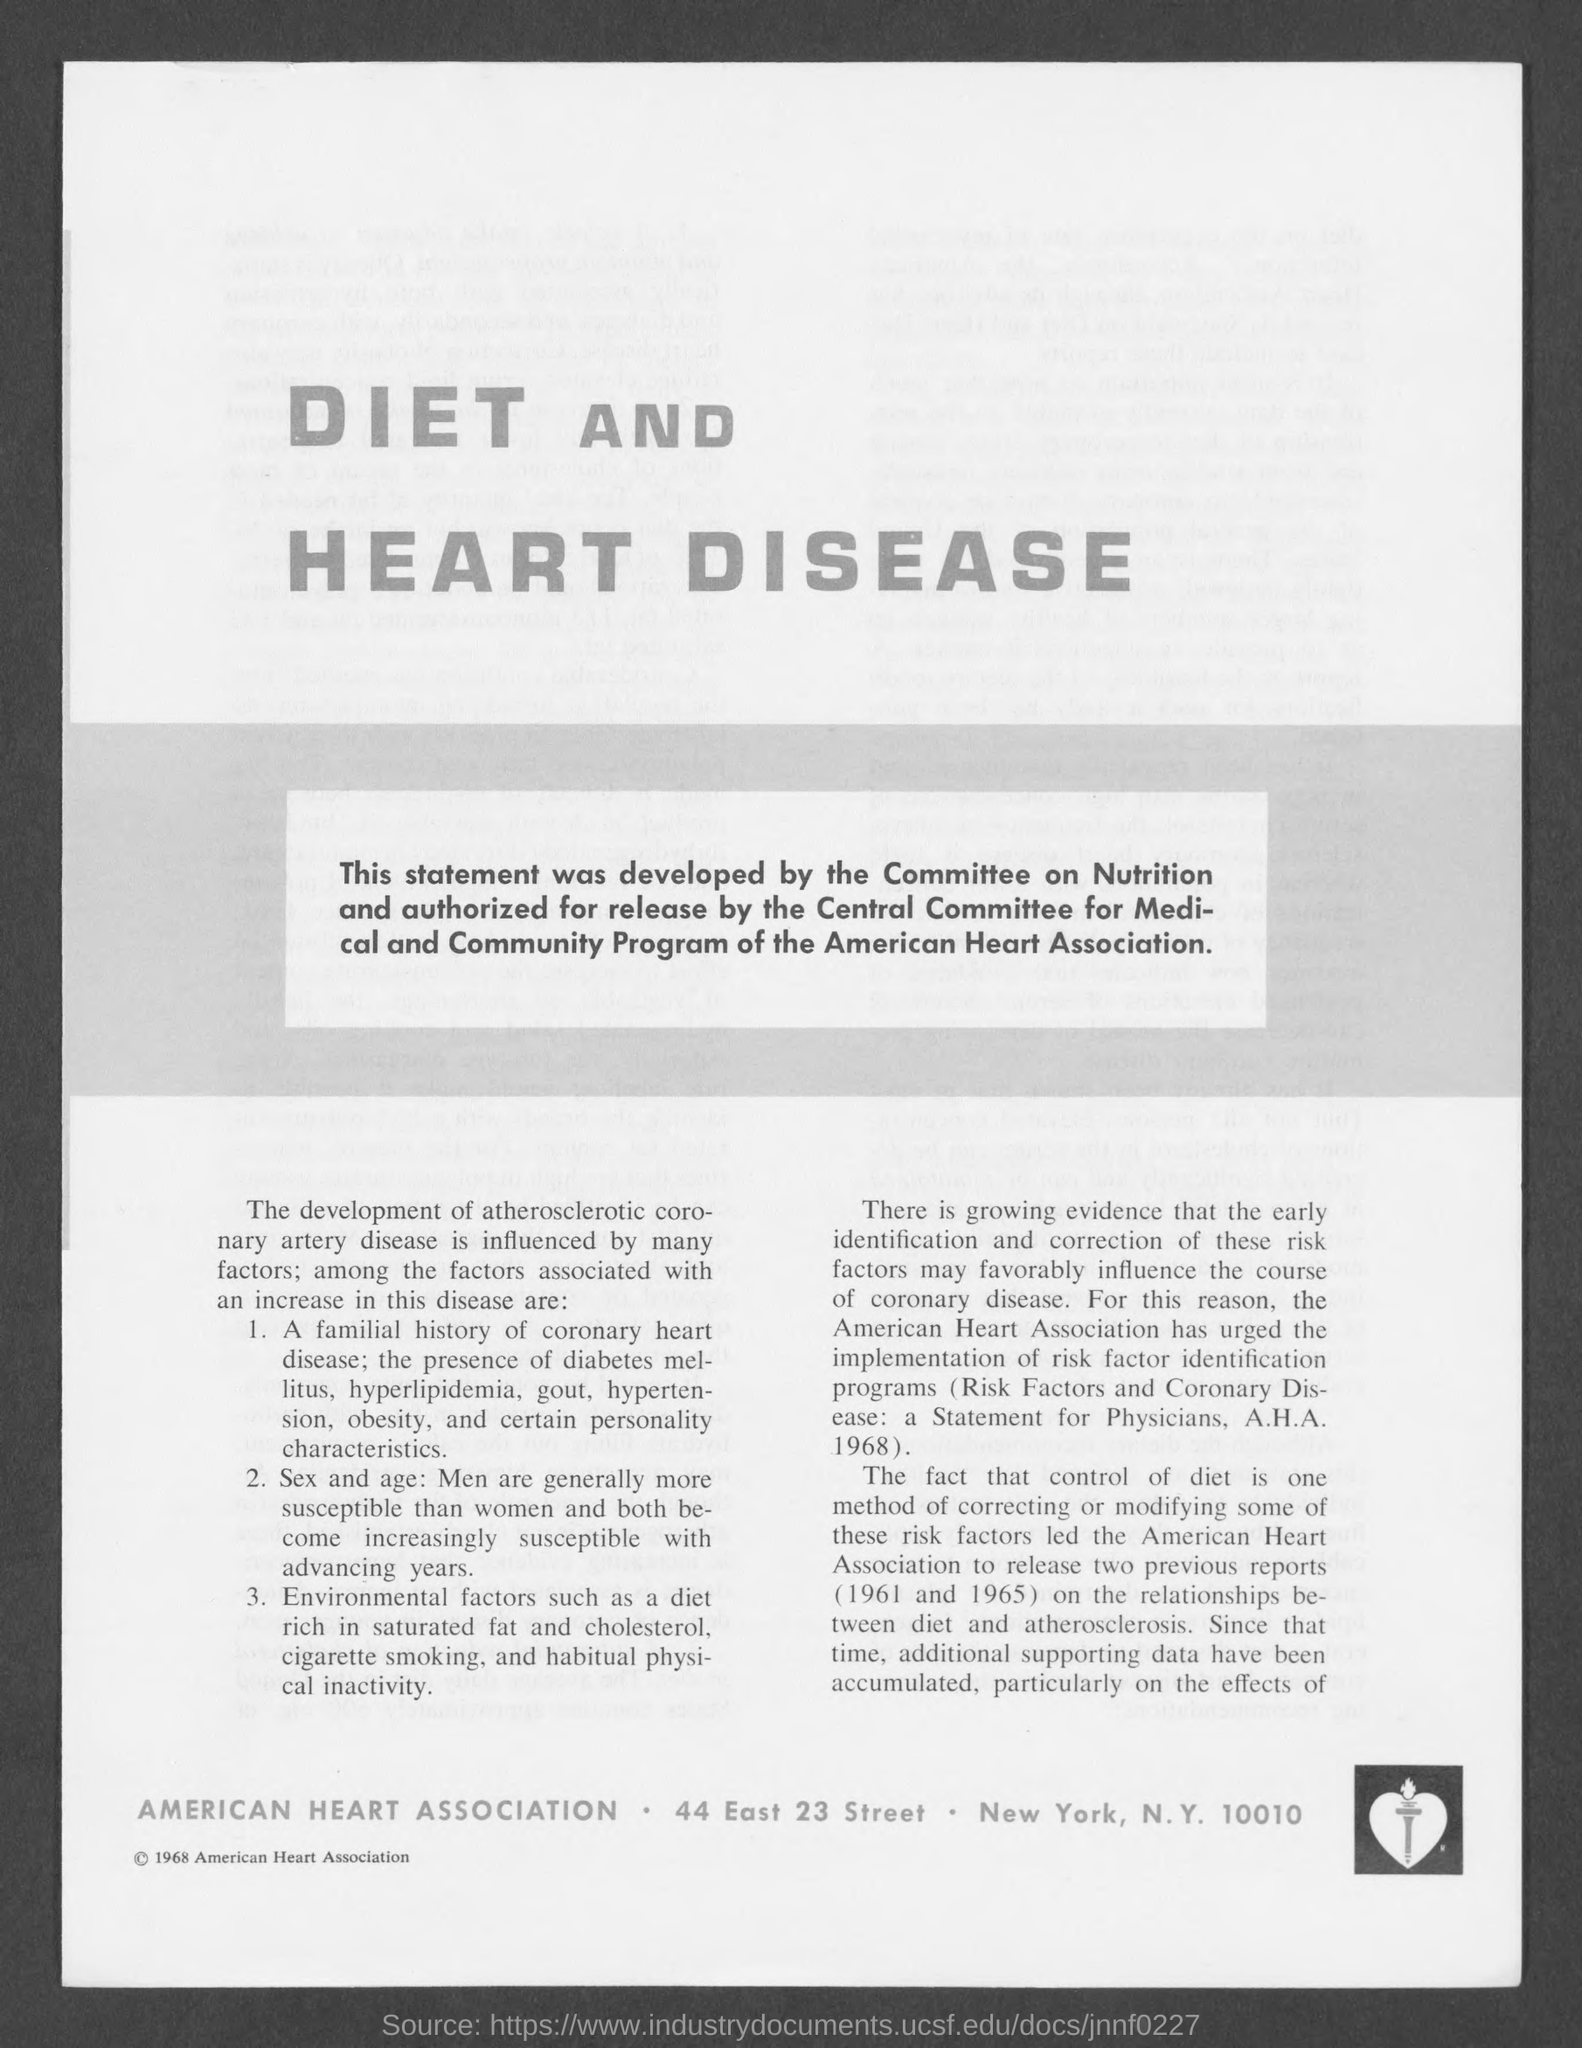In which city is american heart association at?
Offer a terse response. New York. 